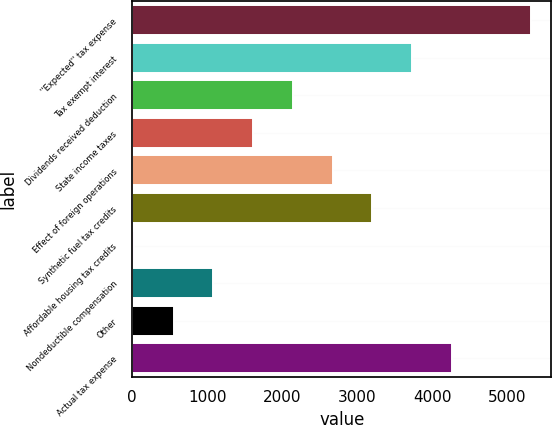Convert chart to OTSL. <chart><loc_0><loc_0><loc_500><loc_500><bar_chart><fcel>''Expected'' tax expense<fcel>Tax exempt interest<fcel>Dividends received deduction<fcel>State income taxes<fcel>Effect of foreign operations<fcel>Synthetic fuel tax credits<fcel>Affordable housing tax credits<fcel>Nondeductible compensation<fcel>Other<fcel>Actual tax expense<nl><fcel>5325<fcel>3734.1<fcel>2143.2<fcel>1612.9<fcel>2673.5<fcel>3203.8<fcel>22<fcel>1082.6<fcel>552.3<fcel>4264.4<nl></chart> 